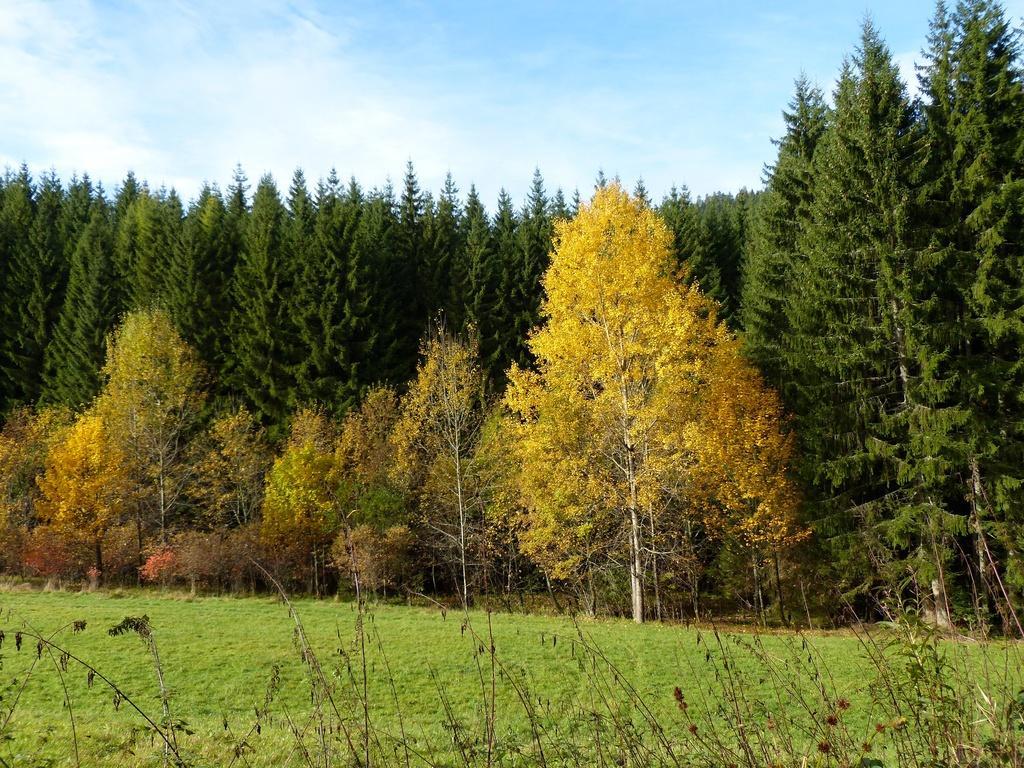In one or two sentences, can you explain what this image depicts? In this image there are trees and there's grass on the ground and sky is cloudy. 